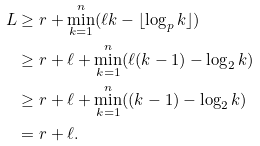<formula> <loc_0><loc_0><loc_500><loc_500>L & \geq r + \min _ { k = 1 } ^ { n } ( \ell k - \lfloor \log _ { p } k \rfloor ) \\ & \geq r + \ell + \min _ { k = 1 } ^ { n } ( \ell ( k - 1 ) - \log _ { 2 } k ) \\ & \geq r + \ell + \min _ { k = 1 } ^ { n } ( ( k - 1 ) - \log _ { 2 } k ) \\ & = r + \ell .</formula> 